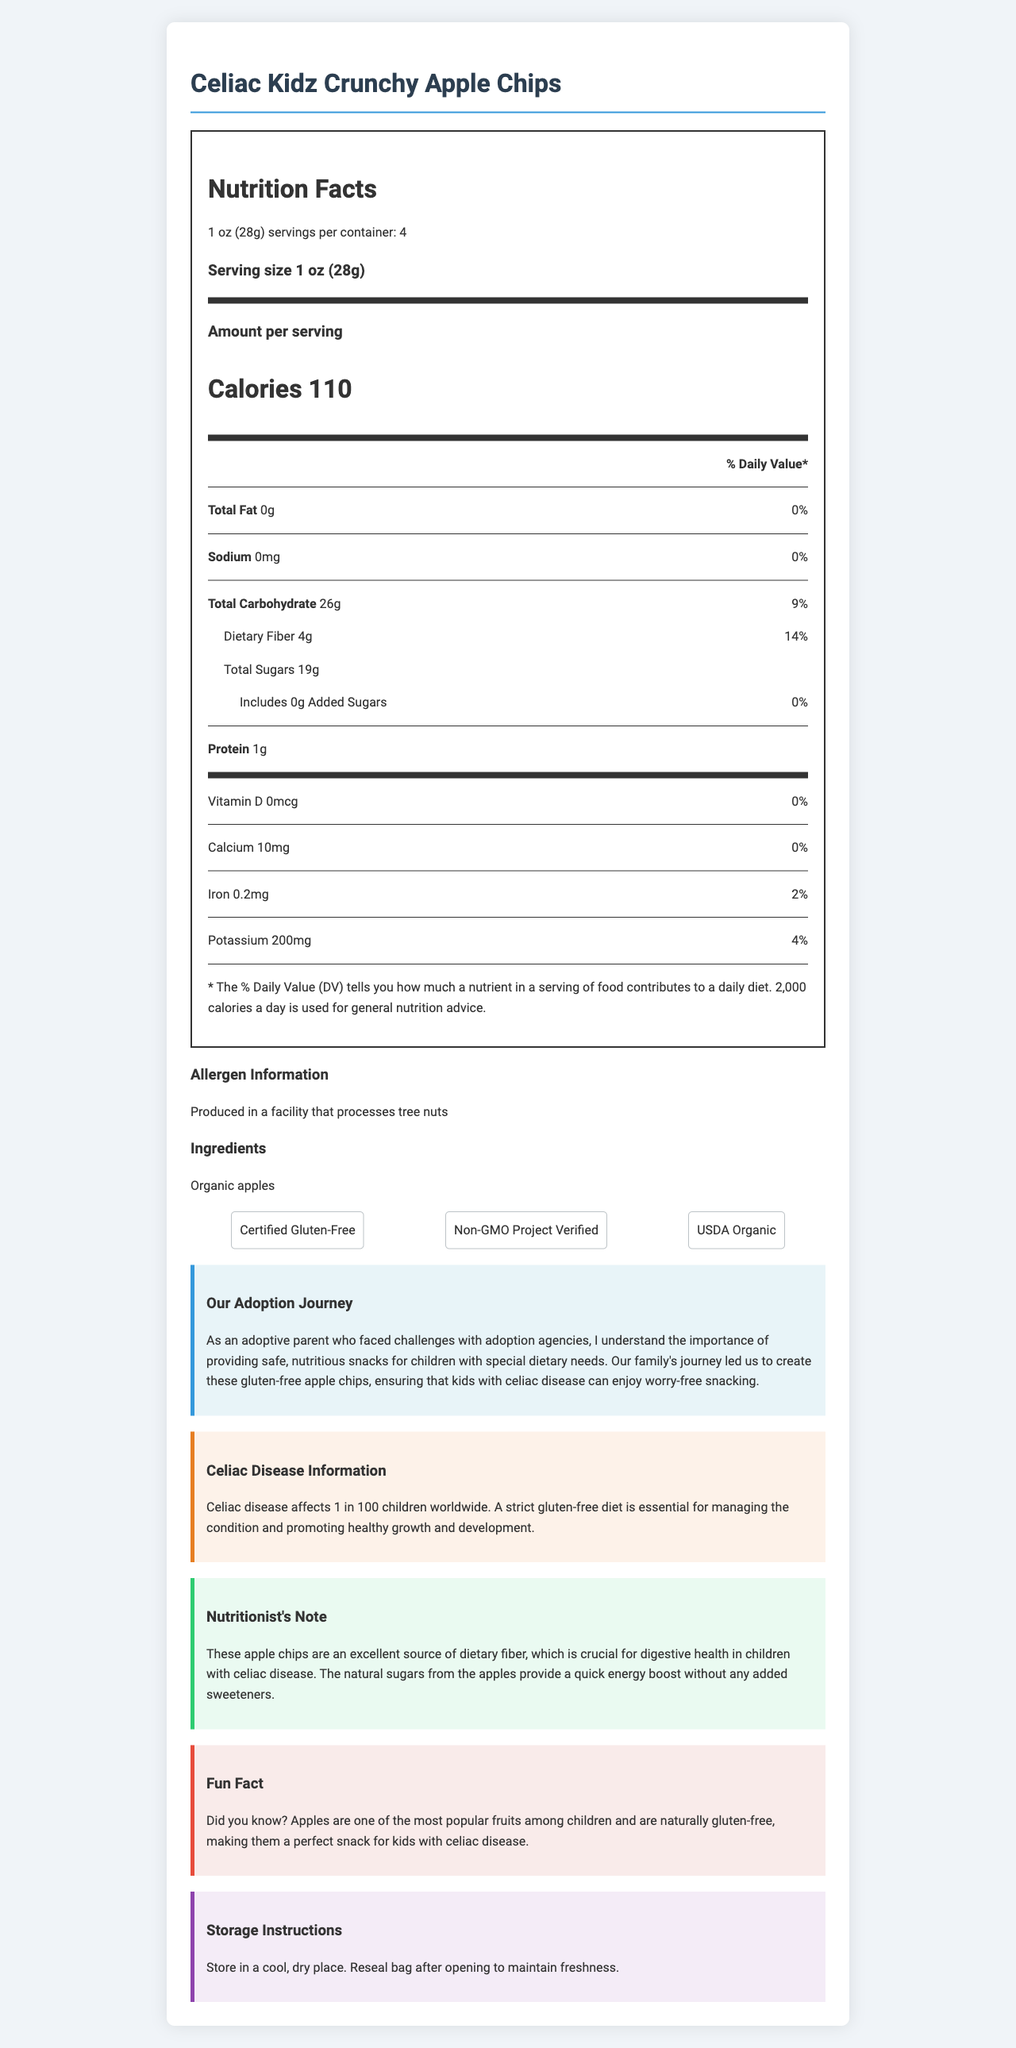what is the product name? The product name is prominently displayed at the top of the document in the title header.
Answer: Celiac Kidz Crunchy Apple Chips how many calories are in one serving? The number of calories per serving is listed in large, bold text within the "Nutrition Facts" section.
Answer: 110 what is the serving size? The serving size is specified at the beginning of the "Nutrition Facts" section.
Answer: 1 oz (28g) what is the total carbohydrate content per serving? The total carbohydrate content is listed under the "Total Carbohydrate" heading in the "Nutrition Facts" section.
Answer: 26g does the product contain any added sugars? The document specifies that the "Total Sugars" amount includes "0g Added Sugars".
Answer: No how much dietary fiber does one serving contain? The dietary fiber content is listed under "Total Carbohydrate" with the specific amount and percentage of daily value.
Answer: 4g what special dietary certifications does this product have? A. Kosher B. Certified Gluten-Free C. Non-GMO Project Verified D. USDA Organic The certifications are listed in the "certifications" section and are "Certified Gluten-Free", "Non-GMO Project Verified", and "USDA Organic".
Answer: B, C, D how much protein is in one serving? A. 0g B. 1g C. 2g D. 3g The protein content per serving is listed as "1g" in the "Nutrition Facts" section.
Answer: B is there any allergen information provided? (yes/no) The document specifies "Produced in a facility that processes tree nuts" under the "Allergen Information" section.
Answer: Yes summarize the main idea of the document. The label details the product's nutritional content, serving size, dietary certifications, and additional context around its creation for children with celiac disease, aiming to assure parents of its safety and benefits.
Answer: The document is a Nutrition Facts label for "Celiac Kidz Crunchy Apple Chips", a gluten-free snack designed for children with celiac disease. It provides detailed nutritional information, allergen information, ingredients, certifications, and additional insights related to celiac disease, the family's adoption journey, and storage instructions. where are the ingredients listed? The ingredients are listed in the "Ingredients" section of the document.
Answer: In the ingredients section why is dietary fiber important for children with celiac disease according to the nutritionist's note? The nutritionist's note mentions that dietary fiber is crucial for digestive health in children with celiac disease.
Answer: For digestive health where should you store these apple chips? The storage instructions state to store the apple chips in a cool, dry place and reseal the bag after opening to maintain freshness.
Answer: In a cool, dry place how much calcium is in one serving? The calcium content per serving is listed as "10mg" in the "Nutrition Facts" section.
Answer: 10mg what is the daily value percentage of iron in one serving? The daily value percentage of iron is listed as "2%" in the "Nutrition Facts" section.
Answer: 2% what is the main ingredient in this product? The document lists "Organic apples" as the main ingredient in the "Ingredients" section.
Answer: Organic apples how many servings are in one container? The "Nutrition Facts" section specifies that there are 4 servings per container.
Answer: 4 are these apple chips a good source of vitamin D? The vitamin D content is listed as "0mcg" with "0%" daily value in the "Nutrition Facts" section.
Answer: No was this product designed with the needs of children with celiac disease in mind? The document includes a section about the adoption journey which mentions that the product was created to ensure that kids with celiac disease can enjoy worry-free snacking, indicating that it was designed with their needs in mind.
Answer: Yes how much potassium is in one serving? The potassium content per serving is listed as "200mg" in the "Nutrition Facts" section.
Answer: 200mg does the document provide specific information about the challenges faced with adoption agencies? While the document mentions an adoptive parent's experience with challenges, it does not provide specific details about these challenges.
Answer: Not enough information 